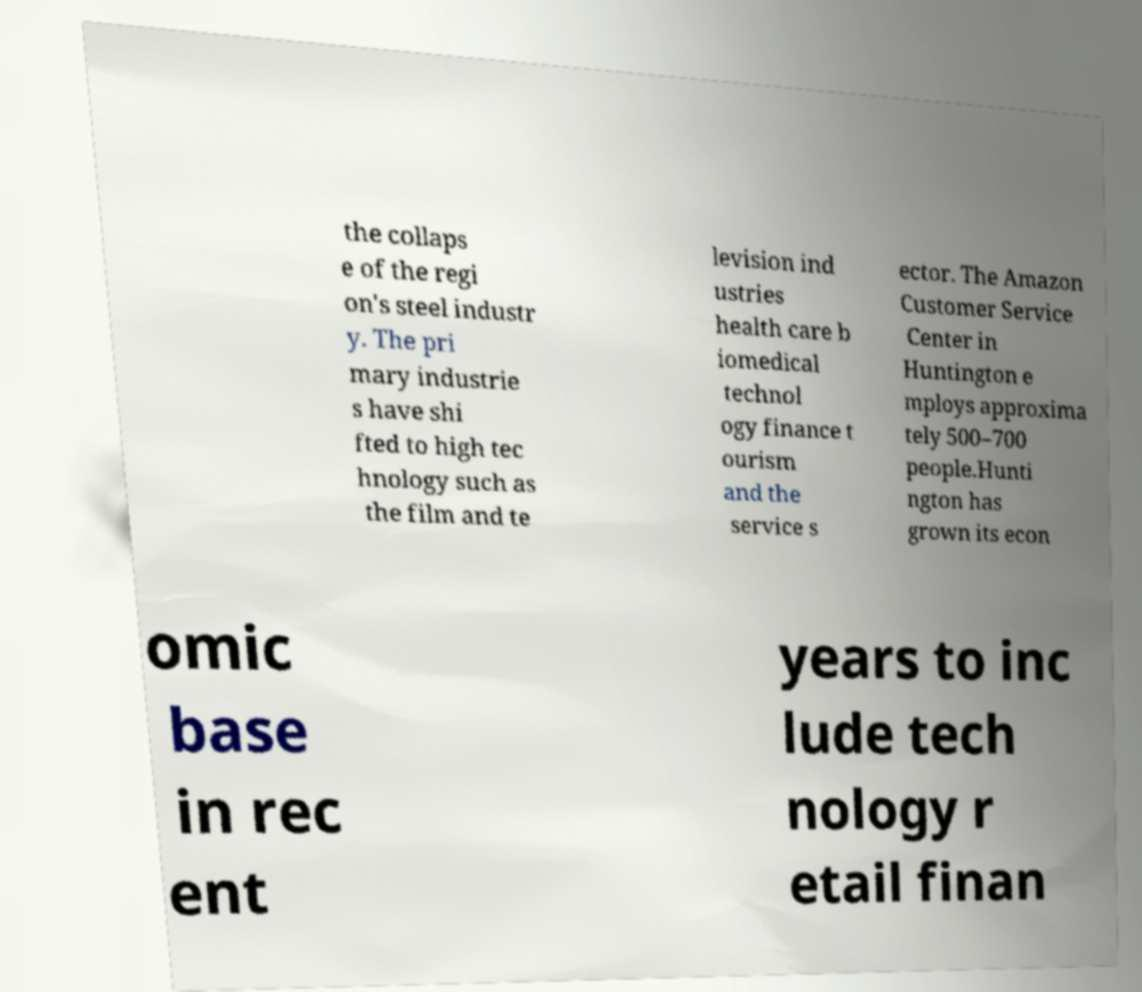Can you read and provide the text displayed in the image?This photo seems to have some interesting text. Can you extract and type it out for me? the collaps e of the regi on's steel industr y. The pri mary industrie s have shi fted to high tec hnology such as the film and te levision ind ustries health care b iomedical technol ogy finance t ourism and the service s ector. The Amazon Customer Service Center in Huntington e mploys approxima tely 500–700 people.Hunti ngton has grown its econ omic base in rec ent years to inc lude tech nology r etail finan 